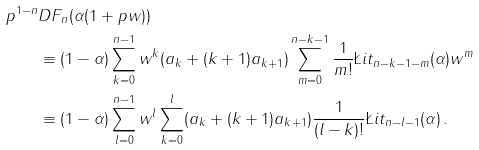Convert formula to latex. <formula><loc_0><loc_0><loc_500><loc_500>p ^ { 1 - n } & D F _ { n } ( \alpha ( 1 + p w ) ) \\ & \equiv ( 1 - \alpha ) \sum _ { k = 0 } ^ { n - 1 } w ^ { k } ( a _ { k } + ( k + 1 ) a _ { k + 1 } ) \sum _ { m = 0 } ^ { n - k - 1 } \frac { 1 } { m ! } \L i t _ { n - k - 1 - m } ( \alpha ) w ^ { m } \\ & \equiv ( 1 - \alpha ) \sum _ { l = 0 } ^ { n - 1 } w ^ { l } \sum _ { k = 0 } ^ { l } ( a _ { k } + ( k + 1 ) a _ { k + 1 } ) \frac { 1 } { ( l - k ) ! } \L i t _ { n - l - 1 } ( \alpha ) \, .</formula> 